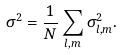<formula> <loc_0><loc_0><loc_500><loc_500>\sigma ^ { 2 } = \frac { 1 } { N } \sum _ { l , m } \sigma _ { l , m } ^ { 2 } .</formula> 